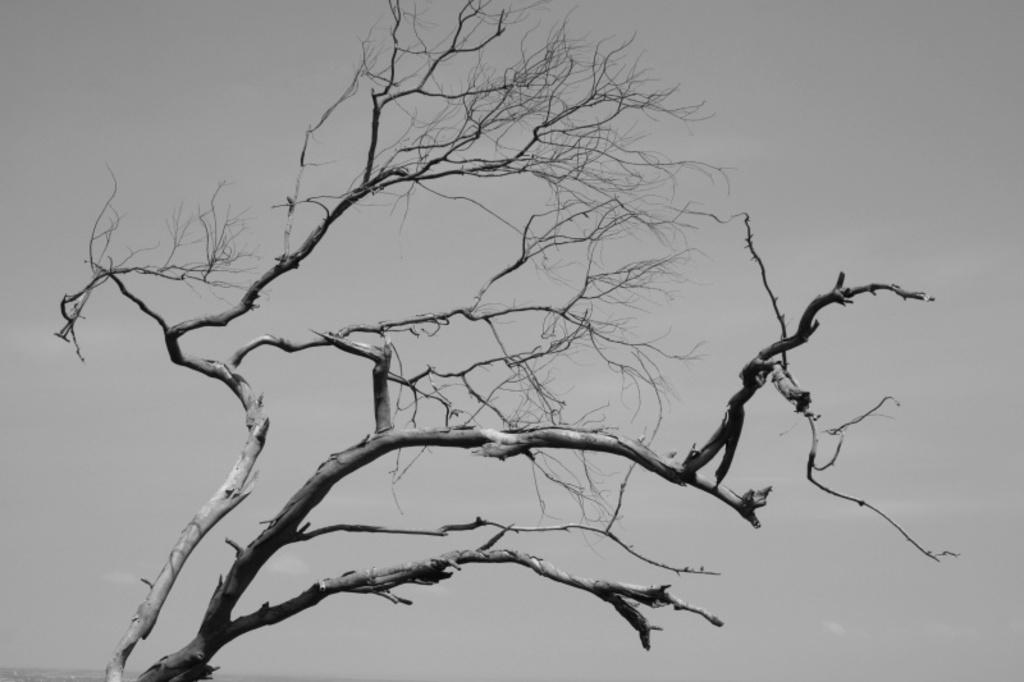What is the color scheme of the image? The image is black and white. What is the main subject in the image? There is a tree in the image. What are the main features of the tree? The tree has stems and branches. Why might the tree appear different from trees we typically see? The tree does not have leaves, which is why it might look different from trees with leaves. What type of trouble can be seen in the image? There is no trouble present in the image; it features a tree with stems, branches, and no leaves. Can you tell me how many bottles are visible in the image? There are no bottles present in the image; it features a tree with stems, branches, and no leaves. 